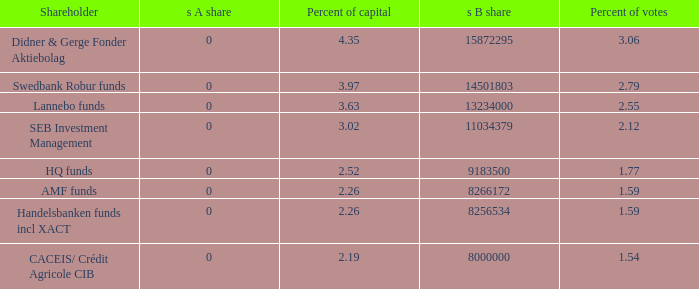What shareholder has 3.63 percent of capital?  Lannebo funds. 